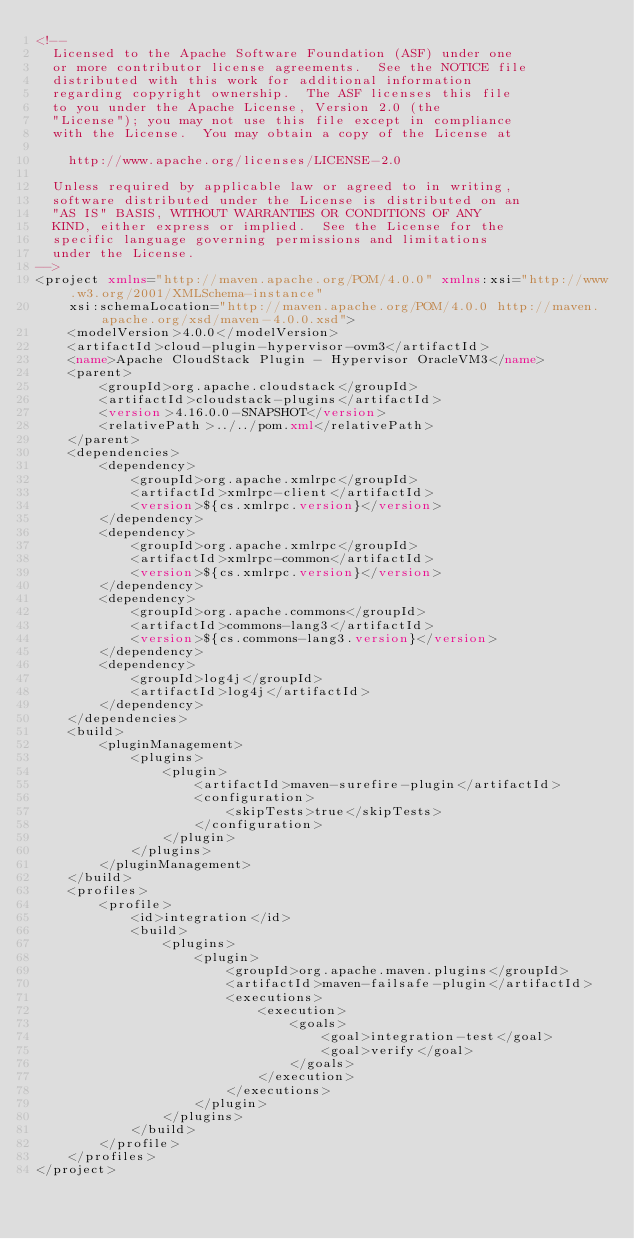<code> <loc_0><loc_0><loc_500><loc_500><_XML_><!--
  Licensed to the Apache Software Foundation (ASF) under one
  or more contributor license agreements.  See the NOTICE file
  distributed with this work for additional information
  regarding copyright ownership.  The ASF licenses this file
  to you under the Apache License, Version 2.0 (the
  "License"); you may not use this file except in compliance
  with the License.  You may obtain a copy of the License at

    http://www.apache.org/licenses/LICENSE-2.0

  Unless required by applicable law or agreed to in writing,
  software distributed under the License is distributed on an
  "AS IS" BASIS, WITHOUT WARRANTIES OR CONDITIONS OF ANY
  KIND, either express or implied.  See the License for the
  specific language governing permissions and limitations
  under the License.
-->
<project xmlns="http://maven.apache.org/POM/4.0.0" xmlns:xsi="http://www.w3.org/2001/XMLSchema-instance"
    xsi:schemaLocation="http://maven.apache.org/POM/4.0.0 http://maven.apache.org/xsd/maven-4.0.0.xsd">
    <modelVersion>4.0.0</modelVersion>
    <artifactId>cloud-plugin-hypervisor-ovm3</artifactId>
    <name>Apache CloudStack Plugin - Hypervisor OracleVM3</name>
    <parent>
        <groupId>org.apache.cloudstack</groupId>
        <artifactId>cloudstack-plugins</artifactId>
        <version>4.16.0.0-SNAPSHOT</version>
        <relativePath>../../pom.xml</relativePath>
    </parent>
    <dependencies>
        <dependency>
            <groupId>org.apache.xmlrpc</groupId>
            <artifactId>xmlrpc-client</artifactId>
            <version>${cs.xmlrpc.version}</version>
        </dependency>
        <dependency>
            <groupId>org.apache.xmlrpc</groupId>
            <artifactId>xmlrpc-common</artifactId>
            <version>${cs.xmlrpc.version}</version>
        </dependency>
        <dependency>
            <groupId>org.apache.commons</groupId>
            <artifactId>commons-lang3</artifactId>
            <version>${cs.commons-lang3.version}</version>
        </dependency>
        <dependency>
            <groupId>log4j</groupId>
            <artifactId>log4j</artifactId>
        </dependency>
    </dependencies>
    <build>
        <pluginManagement>
            <plugins>
                <plugin>
                    <artifactId>maven-surefire-plugin</artifactId>
                    <configuration>
                        <skipTests>true</skipTests>
                    </configuration>
                </plugin>
            </plugins>
        </pluginManagement>
    </build>
    <profiles>
        <profile>
            <id>integration</id>
            <build>
                <plugins>
                    <plugin>
                        <groupId>org.apache.maven.plugins</groupId>
                        <artifactId>maven-failsafe-plugin</artifactId>
                        <executions>
                            <execution>
                                <goals>
                                    <goal>integration-test</goal>
                                    <goal>verify</goal>
                                </goals>
                            </execution>
                        </executions>
                    </plugin>
                </plugins>
            </build>
        </profile>
    </profiles>
</project>
</code> 